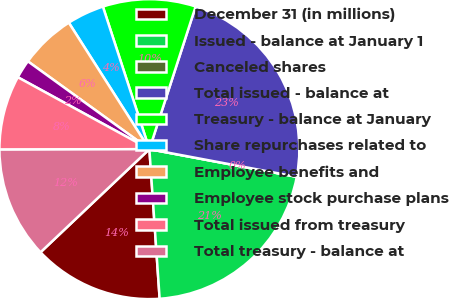Convert chart to OTSL. <chart><loc_0><loc_0><loc_500><loc_500><pie_chart><fcel>December 31 (in millions)<fcel>Issued - balance at January 1<fcel>Canceled shares<fcel>Total issued - balance at<fcel>Treasury - balance at January<fcel>Share repurchases related to<fcel>Employee benefits and<fcel>Employee stock purchase plans<fcel>Total issued from treasury<fcel>Total treasury - balance at<nl><fcel>14.02%<fcel>20.96%<fcel>0.0%<fcel>22.96%<fcel>10.01%<fcel>4.01%<fcel>6.01%<fcel>2.0%<fcel>8.01%<fcel>12.02%<nl></chart> 